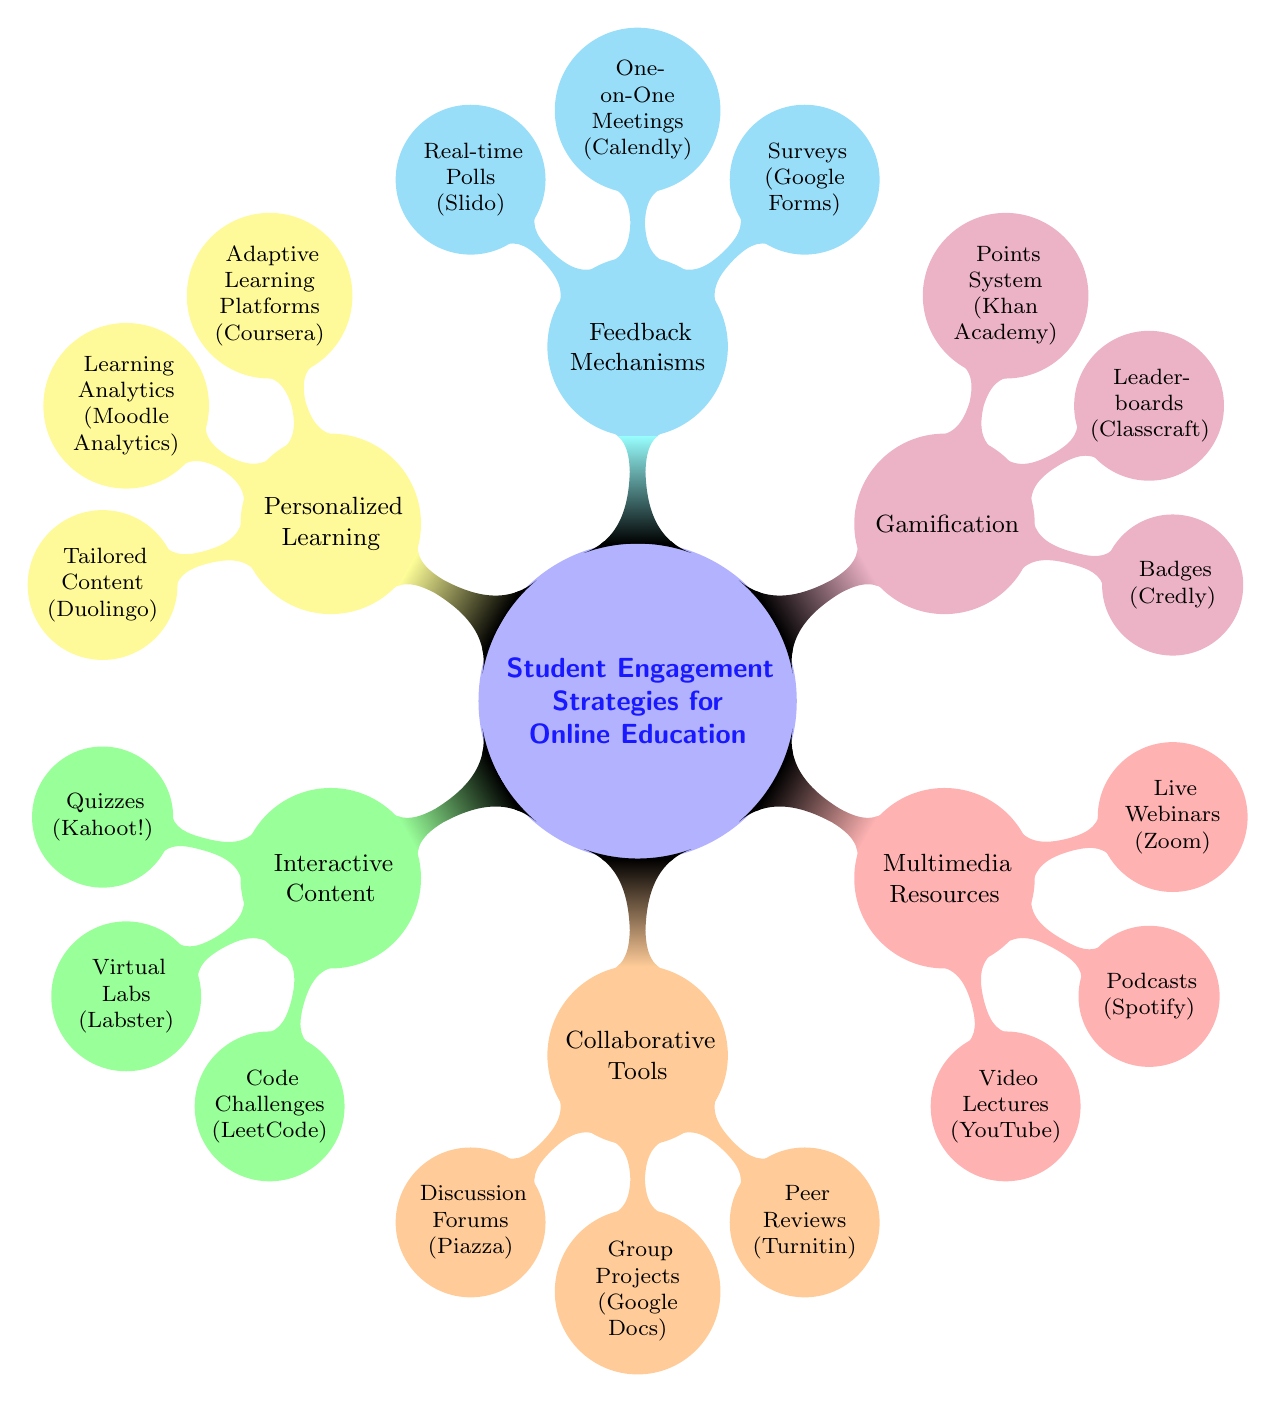What are the three subcategories under Student Engagement Strategies for Online Education? The main category "Student Engagement Strategies for Online Education" has six subcategories: Interactive Content, Collaborative Tools, Multimedia Resources, Gamification, Feedback Mechanisms, and Personalized Learning. By listing them, we see that there are six of them in total.
Answer: Six Which tool is listed under the Gamification strategy? The Gamification strategy includes three tools: Badges with Credly, Leaderboards with Classcraft, and Points System with Khan Academy. Any of those could be named, but since the question asks for one, we can choose either of them, with a clear indication of its use.
Answer: Badges (Credly) How many tools are under Multimedia Resources? The Multimedia Resources branch has three tools listed: Video Lectures (YouTube), Podcasts (Spotify), and Live Webinars (Zoom). To find the number, we just count these tools present in the branch.
Answer: Three Which platform is associated with Adaptive Learning? Under the Personalized Learning category, the Adaptive Learning Platforms is associated with Coursera. We find this by examining the nodes attached to the Personalized Learning category and identifying the platform listed with it.
Answer: Coursera What is the relationship between Peer Reviews and Group Projects? Peer Reviews and Group Projects are both sub-nodes under the Collaborative Tools category. This indicates they belong to the same broader strategy aimed towards collaboration among students.
Answer: Collaborative Tools Which strategy contains the tool Zoom? Zoom is listed under the Multimedia Resources category, specifically as a tool for Live Webinars. By tracing the node directly connected to Zoom, we can see that it falls within the Multimedia Resources strategy.
Answer: Multimedia Resources 